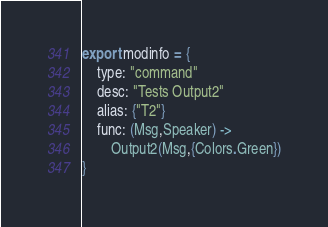<code> <loc_0><loc_0><loc_500><loc_500><_MoonScript_>export modinfo = {
	type: "command"
	desc: "Tests Output2"
	alias: {"T2"}
	func: (Msg,Speaker) ->
		Output2(Msg,{Colors.Green})
}</code> 